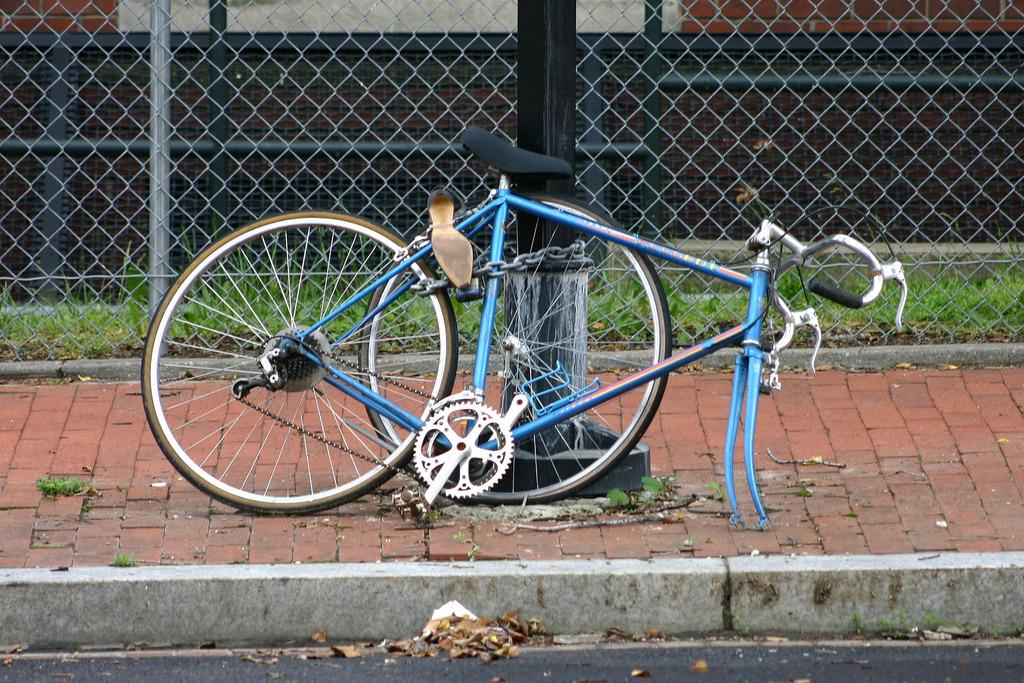What is the main object in the image? There is a bicycle in the image. What other structures or objects can be seen in the image? There is a pillar, grass, a fence, and a wall in the image. What is on the ground in the image? There are leaves on the ground in the image. What type of receipt can be seen hanging from the fence in the image? There is no receipt present in the image; it features a bicycle, a pillar, grass, a fence, and a wall. What part of the human body is visible in the image? There is no part of the human body visible in the image. 